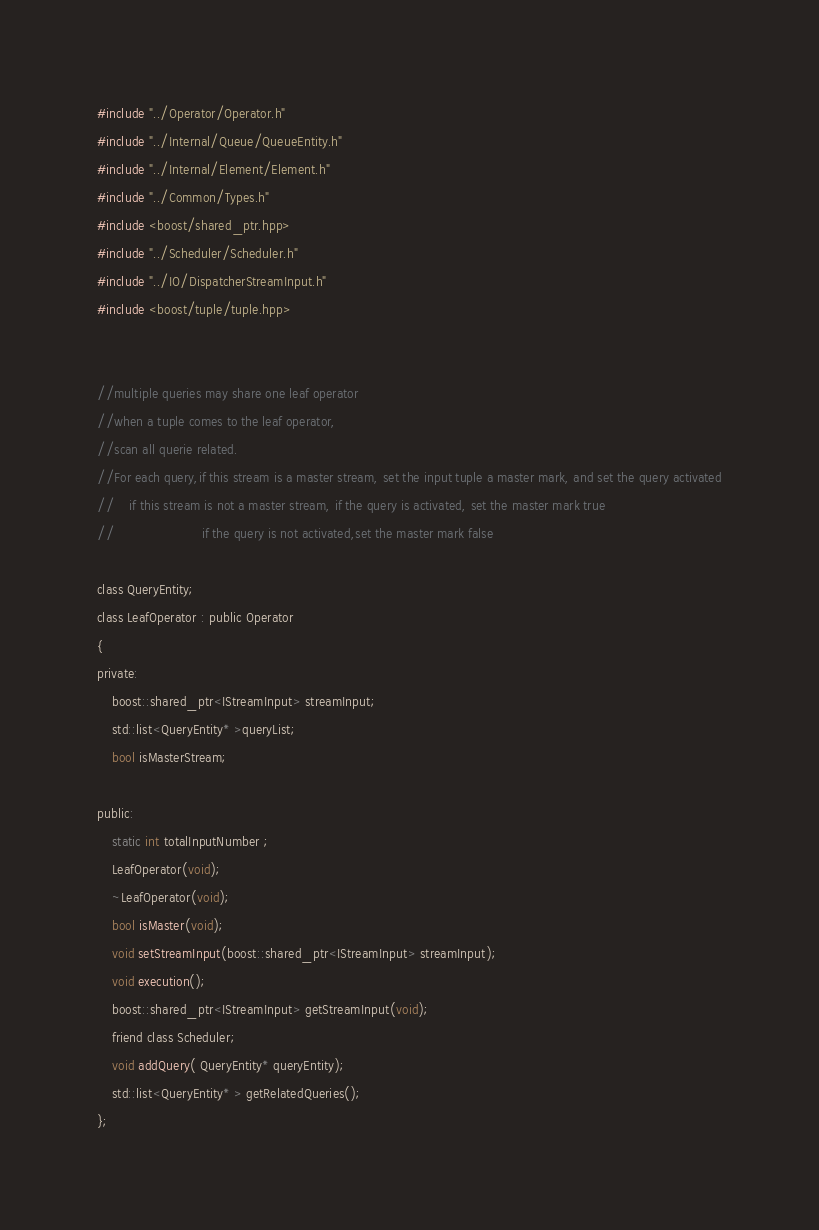Convert code to text. <code><loc_0><loc_0><loc_500><loc_500><_C_>#include "../Operator/Operator.h"
#include "../Internal/Queue/QueueEntity.h"
#include "../Internal/Element/Element.h"
#include "../Common/Types.h"
#include <boost/shared_ptr.hpp>
#include "../Scheduler/Scheduler.h"
#include "../IO/DispatcherStreamInput.h"
#include <boost/tuple/tuple.hpp>


//multiple queries may share one leaf operator
//when a tuple comes to the leaf operator,
//scan all querie related.
//For each query,if this stream is a master stream, set the input tuple a master mark, and set the query activated
//	  if this stream is not a master stream, if the query is activated, set the master mark true
//						 if the query is not activated,set the master mark false

class QueryEntity;
class LeafOperator : public Operator
{
private:
	boost::shared_ptr<IStreamInput> streamInput;
	std::list<QueryEntity* >queryList;
	bool isMasterStream;

public:
	static int totalInputNumber ;
	LeafOperator(void);
	~LeafOperator(void);
	bool isMaster(void);
	void setStreamInput(boost::shared_ptr<IStreamInput> streamInput);
	void execution();
	boost::shared_ptr<IStreamInput> getStreamInput(void);
	friend class Scheduler;
	void addQuery( QueryEntity* queryEntity);
	std::list<QueryEntity* > getRelatedQueries();
};


</code> 